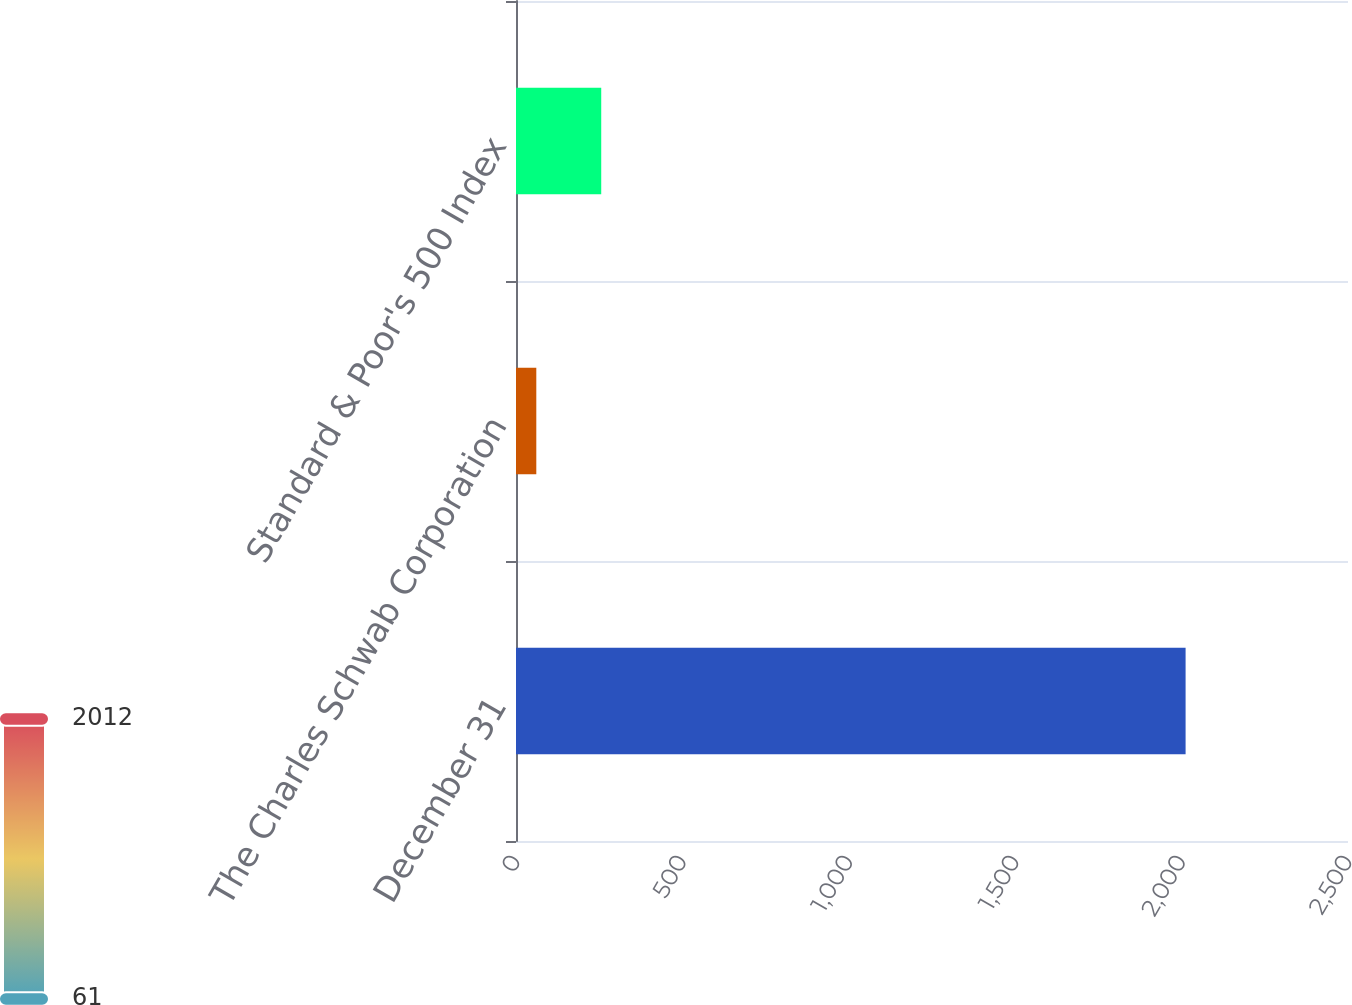<chart> <loc_0><loc_0><loc_500><loc_500><bar_chart><fcel>December 31<fcel>The Charles Schwab Corporation<fcel>Standard & Poor's 500 Index<nl><fcel>2012<fcel>61<fcel>256.1<nl></chart> 